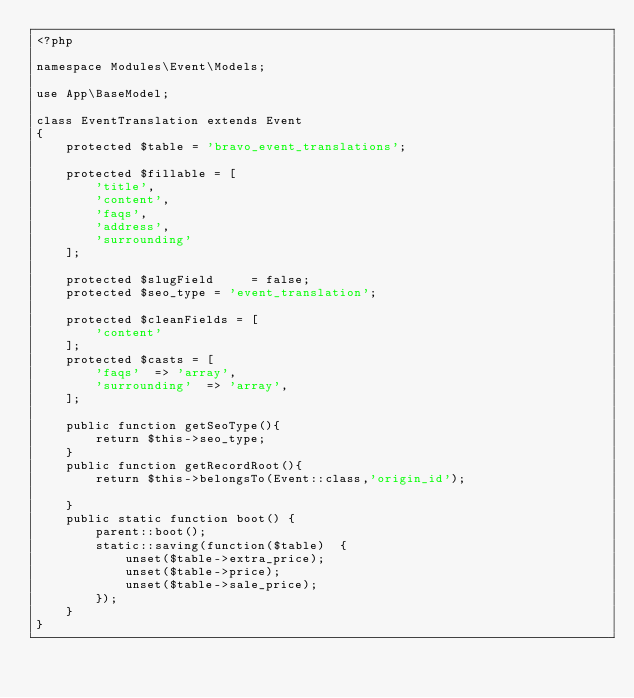<code> <loc_0><loc_0><loc_500><loc_500><_PHP_><?php

namespace Modules\Event\Models;

use App\BaseModel;

class EventTranslation extends Event
{
    protected $table = 'bravo_event_translations';

    protected $fillable = [
        'title',
        'content',
        'faqs',
        'address',
        'surrounding'
    ];

    protected $slugField     = false;
    protected $seo_type = 'event_translation';

    protected $cleanFields = [
        'content'
    ];
    protected $casts = [
        'faqs'  => 'array',
        'surrounding'  => 'array',
    ];

    public function getSeoType(){
        return $this->seo_type;
    }
    public function getRecordRoot(){
        return $this->belongsTo(Event::class,'origin_id');

    }
    public static function boot() {
		parent::boot();
		static::saving(function($table)  {
			unset($table->extra_price);
			unset($table->price);
			unset($table->sale_price);
		});
	}
}
</code> 